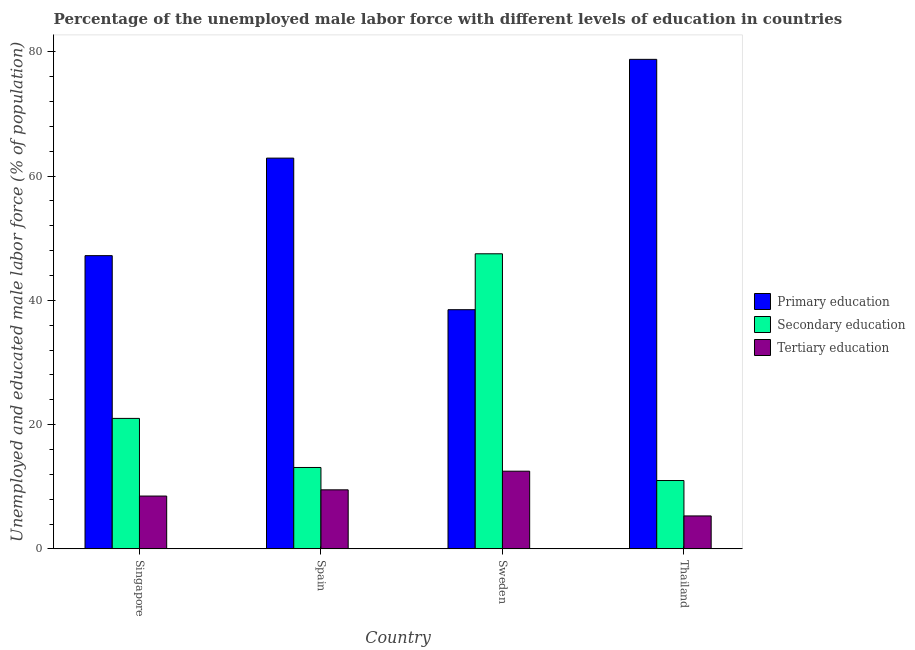How many different coloured bars are there?
Make the answer very short. 3. Are the number of bars per tick equal to the number of legend labels?
Your response must be concise. Yes. How many bars are there on the 4th tick from the left?
Ensure brevity in your answer.  3. What is the label of the 2nd group of bars from the left?
Your response must be concise. Spain. In how many cases, is the number of bars for a given country not equal to the number of legend labels?
Ensure brevity in your answer.  0. What is the percentage of male labor force who received tertiary education in Thailand?
Offer a very short reply. 5.3. Across all countries, what is the minimum percentage of male labor force who received secondary education?
Offer a terse response. 11. What is the total percentage of male labor force who received tertiary education in the graph?
Offer a very short reply. 35.8. What is the difference between the percentage of male labor force who received secondary education in Singapore and that in Sweden?
Your answer should be very brief. -26.5. What is the difference between the percentage of male labor force who received primary education in Singapore and the percentage of male labor force who received secondary education in Spain?
Make the answer very short. 34.1. What is the average percentage of male labor force who received secondary education per country?
Offer a terse response. 23.15. What is the difference between the percentage of male labor force who received secondary education and percentage of male labor force who received tertiary education in Spain?
Your answer should be compact. 3.6. In how many countries, is the percentage of male labor force who received secondary education greater than 72 %?
Your response must be concise. 0. What is the ratio of the percentage of male labor force who received primary education in Spain to that in Thailand?
Give a very brief answer. 0.8. Is the difference between the percentage of male labor force who received tertiary education in Singapore and Sweden greater than the difference between the percentage of male labor force who received primary education in Singapore and Sweden?
Your answer should be compact. No. What is the difference between the highest and the second highest percentage of male labor force who received secondary education?
Your answer should be very brief. 26.5. What is the difference between the highest and the lowest percentage of male labor force who received tertiary education?
Give a very brief answer. 7.2. What does the 3rd bar from the left in Thailand represents?
Offer a very short reply. Tertiary education. What does the 2nd bar from the right in Sweden represents?
Your answer should be very brief. Secondary education. Are all the bars in the graph horizontal?
Provide a short and direct response. No. How many countries are there in the graph?
Offer a very short reply. 4. Are the values on the major ticks of Y-axis written in scientific E-notation?
Offer a very short reply. No. Does the graph contain grids?
Provide a succinct answer. No. How are the legend labels stacked?
Provide a short and direct response. Vertical. What is the title of the graph?
Your response must be concise. Percentage of the unemployed male labor force with different levels of education in countries. Does "Secondary" appear as one of the legend labels in the graph?
Offer a very short reply. No. What is the label or title of the X-axis?
Your answer should be very brief. Country. What is the label or title of the Y-axis?
Ensure brevity in your answer.  Unemployed and educated male labor force (% of population). What is the Unemployed and educated male labor force (% of population) of Primary education in Singapore?
Your answer should be compact. 47.2. What is the Unemployed and educated male labor force (% of population) in Tertiary education in Singapore?
Your answer should be compact. 8.5. What is the Unemployed and educated male labor force (% of population) of Primary education in Spain?
Offer a terse response. 62.9. What is the Unemployed and educated male labor force (% of population) of Secondary education in Spain?
Offer a terse response. 13.1. What is the Unemployed and educated male labor force (% of population) in Primary education in Sweden?
Your response must be concise. 38.5. What is the Unemployed and educated male labor force (% of population) in Secondary education in Sweden?
Ensure brevity in your answer.  47.5. What is the Unemployed and educated male labor force (% of population) of Primary education in Thailand?
Your answer should be compact. 78.8. What is the Unemployed and educated male labor force (% of population) of Secondary education in Thailand?
Offer a very short reply. 11. What is the Unemployed and educated male labor force (% of population) in Tertiary education in Thailand?
Offer a terse response. 5.3. Across all countries, what is the maximum Unemployed and educated male labor force (% of population) of Primary education?
Provide a short and direct response. 78.8. Across all countries, what is the maximum Unemployed and educated male labor force (% of population) in Secondary education?
Keep it short and to the point. 47.5. Across all countries, what is the maximum Unemployed and educated male labor force (% of population) in Tertiary education?
Your answer should be very brief. 12.5. Across all countries, what is the minimum Unemployed and educated male labor force (% of population) in Primary education?
Your response must be concise. 38.5. Across all countries, what is the minimum Unemployed and educated male labor force (% of population) of Secondary education?
Your answer should be very brief. 11. Across all countries, what is the minimum Unemployed and educated male labor force (% of population) in Tertiary education?
Your response must be concise. 5.3. What is the total Unemployed and educated male labor force (% of population) of Primary education in the graph?
Keep it short and to the point. 227.4. What is the total Unemployed and educated male labor force (% of population) in Secondary education in the graph?
Give a very brief answer. 92.6. What is the total Unemployed and educated male labor force (% of population) of Tertiary education in the graph?
Your response must be concise. 35.8. What is the difference between the Unemployed and educated male labor force (% of population) of Primary education in Singapore and that in Spain?
Offer a terse response. -15.7. What is the difference between the Unemployed and educated male labor force (% of population) in Secondary education in Singapore and that in Spain?
Ensure brevity in your answer.  7.9. What is the difference between the Unemployed and educated male labor force (% of population) of Tertiary education in Singapore and that in Spain?
Make the answer very short. -1. What is the difference between the Unemployed and educated male labor force (% of population) of Secondary education in Singapore and that in Sweden?
Ensure brevity in your answer.  -26.5. What is the difference between the Unemployed and educated male labor force (% of population) of Primary education in Singapore and that in Thailand?
Provide a short and direct response. -31.6. What is the difference between the Unemployed and educated male labor force (% of population) of Primary education in Spain and that in Sweden?
Offer a very short reply. 24.4. What is the difference between the Unemployed and educated male labor force (% of population) in Secondary education in Spain and that in Sweden?
Offer a terse response. -34.4. What is the difference between the Unemployed and educated male labor force (% of population) of Tertiary education in Spain and that in Sweden?
Provide a succinct answer. -3. What is the difference between the Unemployed and educated male labor force (% of population) in Primary education in Spain and that in Thailand?
Offer a terse response. -15.9. What is the difference between the Unemployed and educated male labor force (% of population) of Secondary education in Spain and that in Thailand?
Your answer should be compact. 2.1. What is the difference between the Unemployed and educated male labor force (% of population) in Tertiary education in Spain and that in Thailand?
Your answer should be compact. 4.2. What is the difference between the Unemployed and educated male labor force (% of population) of Primary education in Sweden and that in Thailand?
Your response must be concise. -40.3. What is the difference between the Unemployed and educated male labor force (% of population) of Secondary education in Sweden and that in Thailand?
Offer a very short reply. 36.5. What is the difference between the Unemployed and educated male labor force (% of population) of Primary education in Singapore and the Unemployed and educated male labor force (% of population) of Secondary education in Spain?
Provide a succinct answer. 34.1. What is the difference between the Unemployed and educated male labor force (% of population) in Primary education in Singapore and the Unemployed and educated male labor force (% of population) in Tertiary education in Spain?
Provide a succinct answer. 37.7. What is the difference between the Unemployed and educated male labor force (% of population) in Primary education in Singapore and the Unemployed and educated male labor force (% of population) in Tertiary education in Sweden?
Offer a very short reply. 34.7. What is the difference between the Unemployed and educated male labor force (% of population) in Primary education in Singapore and the Unemployed and educated male labor force (% of population) in Secondary education in Thailand?
Offer a very short reply. 36.2. What is the difference between the Unemployed and educated male labor force (% of population) in Primary education in Singapore and the Unemployed and educated male labor force (% of population) in Tertiary education in Thailand?
Offer a terse response. 41.9. What is the difference between the Unemployed and educated male labor force (% of population) of Primary education in Spain and the Unemployed and educated male labor force (% of population) of Tertiary education in Sweden?
Provide a succinct answer. 50.4. What is the difference between the Unemployed and educated male labor force (% of population) of Secondary education in Spain and the Unemployed and educated male labor force (% of population) of Tertiary education in Sweden?
Provide a succinct answer. 0.6. What is the difference between the Unemployed and educated male labor force (% of population) of Primary education in Spain and the Unemployed and educated male labor force (% of population) of Secondary education in Thailand?
Your answer should be compact. 51.9. What is the difference between the Unemployed and educated male labor force (% of population) of Primary education in Spain and the Unemployed and educated male labor force (% of population) of Tertiary education in Thailand?
Make the answer very short. 57.6. What is the difference between the Unemployed and educated male labor force (% of population) in Secondary education in Spain and the Unemployed and educated male labor force (% of population) in Tertiary education in Thailand?
Your response must be concise. 7.8. What is the difference between the Unemployed and educated male labor force (% of population) of Primary education in Sweden and the Unemployed and educated male labor force (% of population) of Tertiary education in Thailand?
Your response must be concise. 33.2. What is the difference between the Unemployed and educated male labor force (% of population) of Secondary education in Sweden and the Unemployed and educated male labor force (% of population) of Tertiary education in Thailand?
Give a very brief answer. 42.2. What is the average Unemployed and educated male labor force (% of population) in Primary education per country?
Your answer should be compact. 56.85. What is the average Unemployed and educated male labor force (% of population) in Secondary education per country?
Ensure brevity in your answer.  23.15. What is the average Unemployed and educated male labor force (% of population) of Tertiary education per country?
Your answer should be very brief. 8.95. What is the difference between the Unemployed and educated male labor force (% of population) of Primary education and Unemployed and educated male labor force (% of population) of Secondary education in Singapore?
Your answer should be very brief. 26.2. What is the difference between the Unemployed and educated male labor force (% of population) of Primary education and Unemployed and educated male labor force (% of population) of Tertiary education in Singapore?
Offer a terse response. 38.7. What is the difference between the Unemployed and educated male labor force (% of population) of Secondary education and Unemployed and educated male labor force (% of population) of Tertiary education in Singapore?
Make the answer very short. 12.5. What is the difference between the Unemployed and educated male labor force (% of population) of Primary education and Unemployed and educated male labor force (% of population) of Secondary education in Spain?
Offer a terse response. 49.8. What is the difference between the Unemployed and educated male labor force (% of population) of Primary education and Unemployed and educated male labor force (% of population) of Tertiary education in Spain?
Provide a succinct answer. 53.4. What is the difference between the Unemployed and educated male labor force (% of population) in Primary education and Unemployed and educated male labor force (% of population) in Secondary education in Sweden?
Your answer should be compact. -9. What is the difference between the Unemployed and educated male labor force (% of population) of Primary education and Unemployed and educated male labor force (% of population) of Tertiary education in Sweden?
Offer a terse response. 26. What is the difference between the Unemployed and educated male labor force (% of population) of Primary education and Unemployed and educated male labor force (% of population) of Secondary education in Thailand?
Provide a short and direct response. 67.8. What is the difference between the Unemployed and educated male labor force (% of population) in Primary education and Unemployed and educated male labor force (% of population) in Tertiary education in Thailand?
Give a very brief answer. 73.5. What is the difference between the Unemployed and educated male labor force (% of population) of Secondary education and Unemployed and educated male labor force (% of population) of Tertiary education in Thailand?
Provide a short and direct response. 5.7. What is the ratio of the Unemployed and educated male labor force (% of population) in Primary education in Singapore to that in Spain?
Offer a terse response. 0.75. What is the ratio of the Unemployed and educated male labor force (% of population) of Secondary education in Singapore to that in Spain?
Offer a terse response. 1.6. What is the ratio of the Unemployed and educated male labor force (% of population) in Tertiary education in Singapore to that in Spain?
Ensure brevity in your answer.  0.89. What is the ratio of the Unemployed and educated male labor force (% of population) of Primary education in Singapore to that in Sweden?
Ensure brevity in your answer.  1.23. What is the ratio of the Unemployed and educated male labor force (% of population) of Secondary education in Singapore to that in Sweden?
Your answer should be very brief. 0.44. What is the ratio of the Unemployed and educated male labor force (% of population) of Tertiary education in Singapore to that in Sweden?
Your answer should be compact. 0.68. What is the ratio of the Unemployed and educated male labor force (% of population) of Primary education in Singapore to that in Thailand?
Ensure brevity in your answer.  0.6. What is the ratio of the Unemployed and educated male labor force (% of population) of Secondary education in Singapore to that in Thailand?
Give a very brief answer. 1.91. What is the ratio of the Unemployed and educated male labor force (% of population) of Tertiary education in Singapore to that in Thailand?
Your response must be concise. 1.6. What is the ratio of the Unemployed and educated male labor force (% of population) in Primary education in Spain to that in Sweden?
Offer a terse response. 1.63. What is the ratio of the Unemployed and educated male labor force (% of population) in Secondary education in Spain to that in Sweden?
Provide a succinct answer. 0.28. What is the ratio of the Unemployed and educated male labor force (% of population) in Tertiary education in Spain to that in Sweden?
Keep it short and to the point. 0.76. What is the ratio of the Unemployed and educated male labor force (% of population) of Primary education in Spain to that in Thailand?
Your answer should be compact. 0.8. What is the ratio of the Unemployed and educated male labor force (% of population) of Secondary education in Spain to that in Thailand?
Provide a succinct answer. 1.19. What is the ratio of the Unemployed and educated male labor force (% of population) of Tertiary education in Spain to that in Thailand?
Offer a terse response. 1.79. What is the ratio of the Unemployed and educated male labor force (% of population) of Primary education in Sweden to that in Thailand?
Keep it short and to the point. 0.49. What is the ratio of the Unemployed and educated male labor force (% of population) of Secondary education in Sweden to that in Thailand?
Offer a terse response. 4.32. What is the ratio of the Unemployed and educated male labor force (% of population) in Tertiary education in Sweden to that in Thailand?
Your answer should be very brief. 2.36. What is the difference between the highest and the second highest Unemployed and educated male labor force (% of population) in Secondary education?
Provide a succinct answer. 26.5. What is the difference between the highest and the second highest Unemployed and educated male labor force (% of population) of Tertiary education?
Your answer should be compact. 3. What is the difference between the highest and the lowest Unemployed and educated male labor force (% of population) of Primary education?
Your answer should be compact. 40.3. What is the difference between the highest and the lowest Unemployed and educated male labor force (% of population) in Secondary education?
Keep it short and to the point. 36.5. What is the difference between the highest and the lowest Unemployed and educated male labor force (% of population) in Tertiary education?
Ensure brevity in your answer.  7.2. 